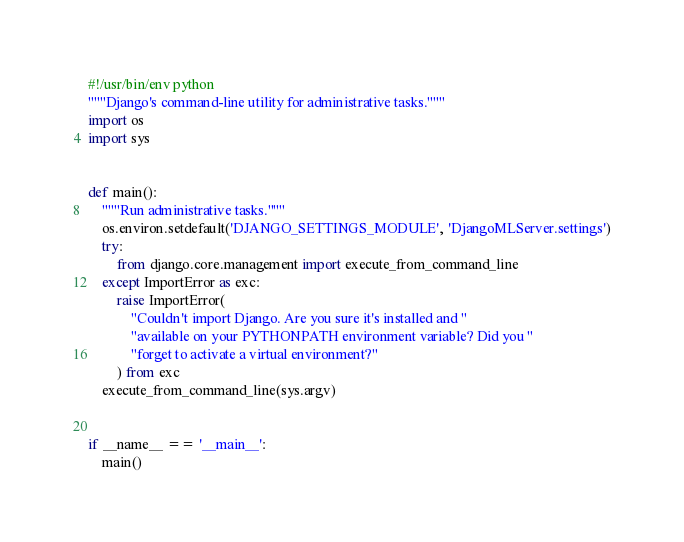Convert code to text. <code><loc_0><loc_0><loc_500><loc_500><_Python_>#!/usr/bin/env python
"""Django's command-line utility for administrative tasks."""
import os
import sys


def main():
    """Run administrative tasks."""
    os.environ.setdefault('DJANGO_SETTINGS_MODULE', 'DjangoMLServer.settings')
    try:
        from django.core.management import execute_from_command_line
    except ImportError as exc:
        raise ImportError(
            "Couldn't import Django. Are you sure it's installed and "
            "available on your PYTHONPATH environment variable? Did you "
            "forget to activate a virtual environment?"
        ) from exc
    execute_from_command_line(sys.argv)


if __name__ == '__main__':
    main()
</code> 